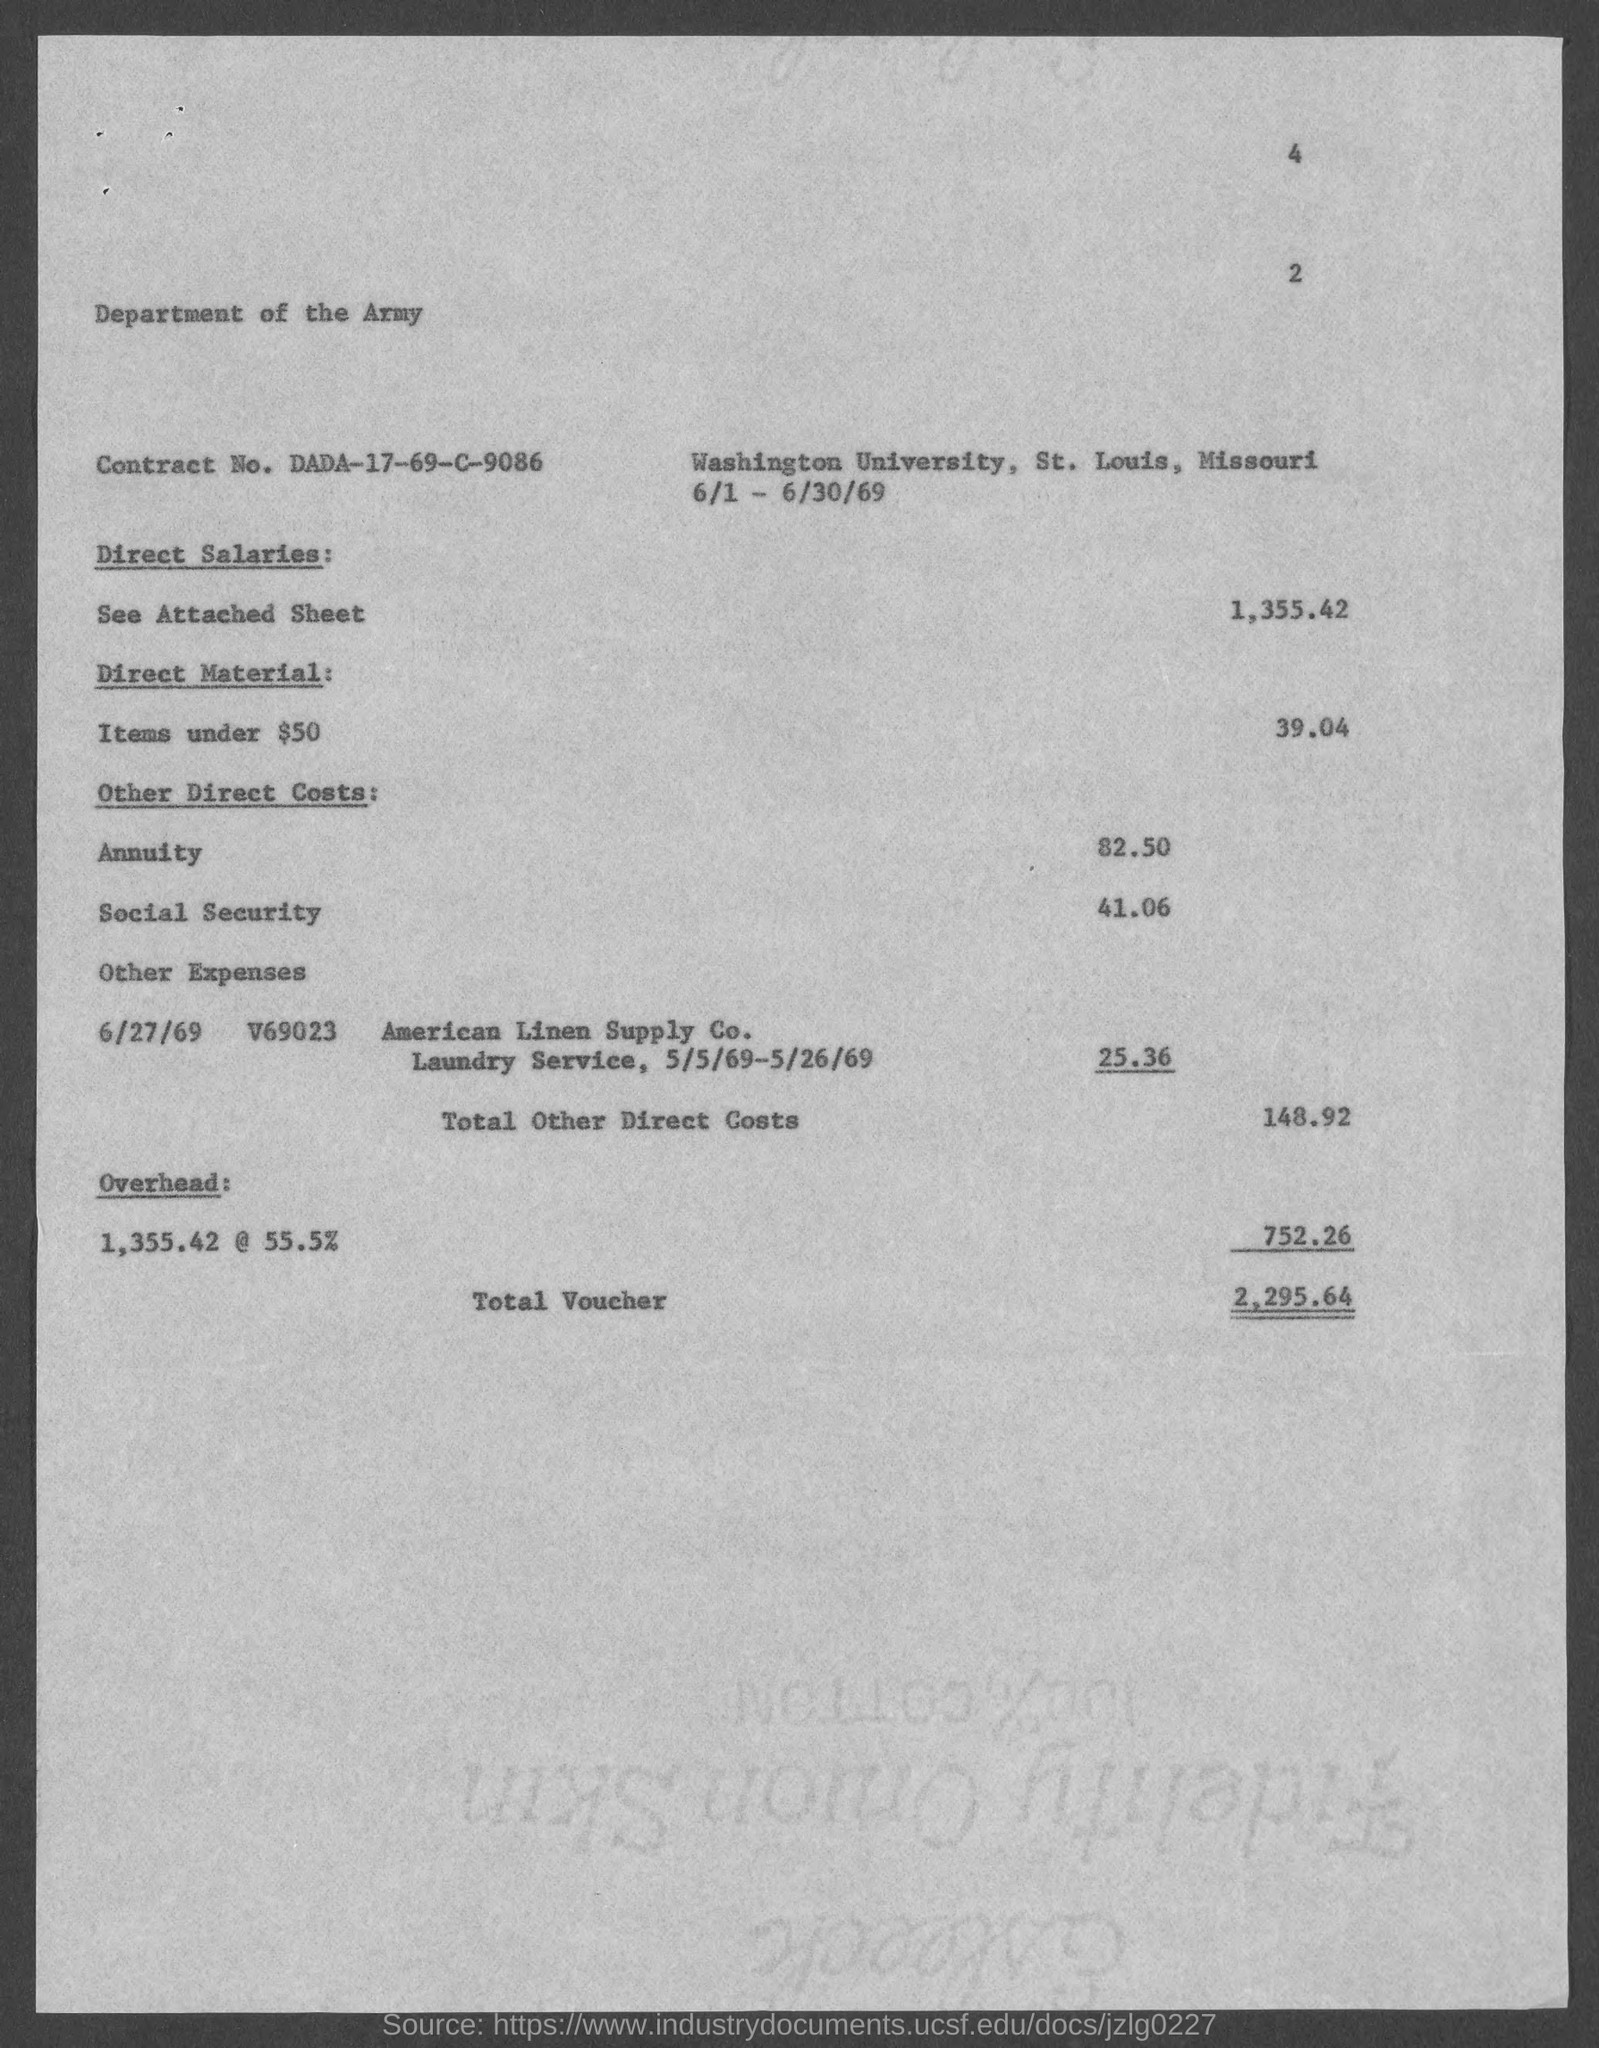List a handful of essential elements in this visual. The total voucher amount mentioned in the document is 2,295.64 The social security cost mentioned in the document is $41.06. The Contract No. as mentioned in the document is DADA-17-69-C-9086.. The direct material cost for items under $50, as stated in the document, is 39.04. The annuity cost mentioned in the document is 82.50... 